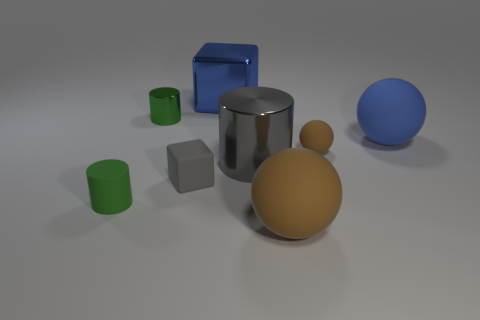There is a brown matte object that is in front of the big shiny cylinder; does it have the same shape as the gray metal object?
Keep it short and to the point. No. There is a shiny cylinder that is the same color as the rubber cube; what size is it?
Your response must be concise. Large. Is there a red shiny cylinder that has the same size as the gray matte block?
Keep it short and to the point. No. There is a cube that is behind the big sphere right of the small brown matte thing; is there a brown matte sphere behind it?
Keep it short and to the point. No. There is a large cylinder; is its color the same as the tiny cylinder right of the tiny green matte cylinder?
Provide a succinct answer. No. What is the material of the small cylinder behind the big matte object that is right of the rubber sphere in front of the large cylinder?
Give a very brief answer. Metal. What shape is the shiny thing that is left of the blue metal cube?
Your response must be concise. Cylinder. What size is the cylinder that is the same material as the big blue sphere?
Your answer should be very brief. Small. How many yellow metal things are the same shape as the blue matte object?
Give a very brief answer. 0. Is the color of the large ball that is behind the tiny brown rubber thing the same as the large cylinder?
Offer a terse response. No. 